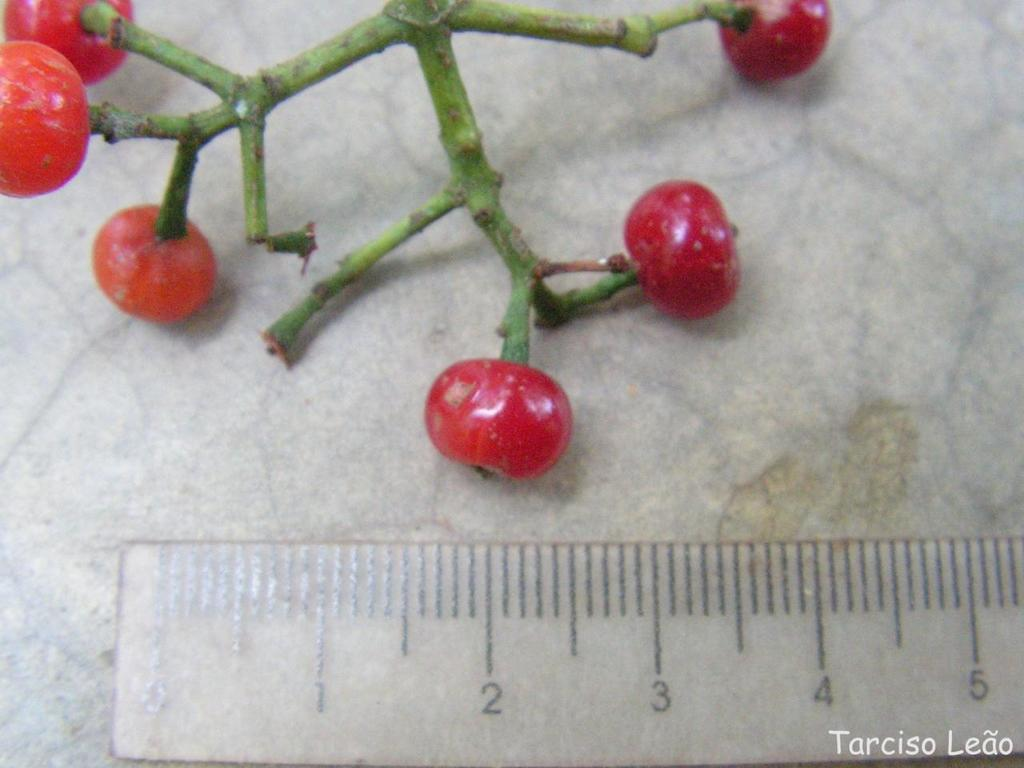<image>
Relay a brief, clear account of the picture shown. A ruler showing 5 centimeters is placed below a branch of fruit. 